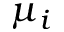<formula> <loc_0><loc_0><loc_500><loc_500>\mu _ { i }</formula> 